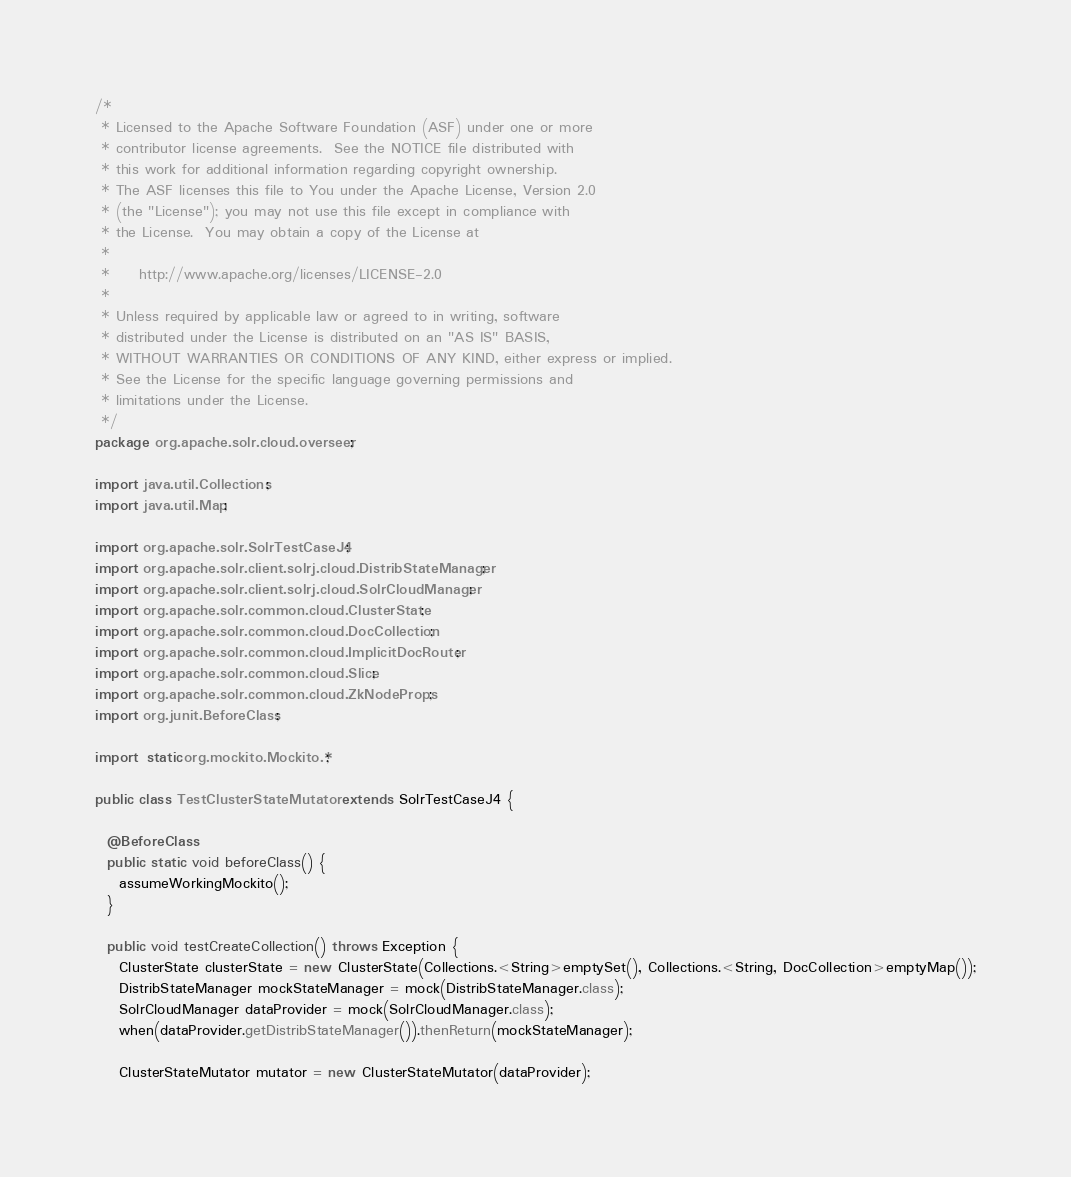Convert code to text. <code><loc_0><loc_0><loc_500><loc_500><_Java_>/*
 * Licensed to the Apache Software Foundation (ASF) under one or more
 * contributor license agreements.  See the NOTICE file distributed with
 * this work for additional information regarding copyright ownership.
 * The ASF licenses this file to You under the Apache License, Version 2.0
 * (the "License"); you may not use this file except in compliance with
 * the License.  You may obtain a copy of the License at
 *
 *     http://www.apache.org/licenses/LICENSE-2.0
 *
 * Unless required by applicable law or agreed to in writing, software
 * distributed under the License is distributed on an "AS IS" BASIS,
 * WITHOUT WARRANTIES OR CONDITIONS OF ANY KIND, either express or implied.
 * See the License for the specific language governing permissions and
 * limitations under the License.
 */
package org.apache.solr.cloud.overseer;

import java.util.Collections;
import java.util.Map;

import org.apache.solr.SolrTestCaseJ4;
import org.apache.solr.client.solrj.cloud.DistribStateManager;
import org.apache.solr.client.solrj.cloud.SolrCloudManager;
import org.apache.solr.common.cloud.ClusterState;
import org.apache.solr.common.cloud.DocCollection;
import org.apache.solr.common.cloud.ImplicitDocRouter;
import org.apache.solr.common.cloud.Slice;
import org.apache.solr.common.cloud.ZkNodeProps;
import org.junit.BeforeClass;

import static org.mockito.Mockito.*;

public class TestClusterStateMutator extends SolrTestCaseJ4 {
  
  @BeforeClass
  public static void beforeClass() {
    assumeWorkingMockito();
  }
  
  public void testCreateCollection() throws Exception {
    ClusterState clusterState = new ClusterState(Collections.<String>emptySet(), Collections.<String, DocCollection>emptyMap());
    DistribStateManager mockStateManager = mock(DistribStateManager.class);
    SolrCloudManager dataProvider = mock(SolrCloudManager.class);
    when(dataProvider.getDistribStateManager()).thenReturn(mockStateManager);

    ClusterStateMutator mutator = new ClusterStateMutator(dataProvider);</code> 